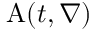Convert formula to latex. <formula><loc_0><loc_0><loc_500><loc_500>A ( t , \nabla )</formula> 